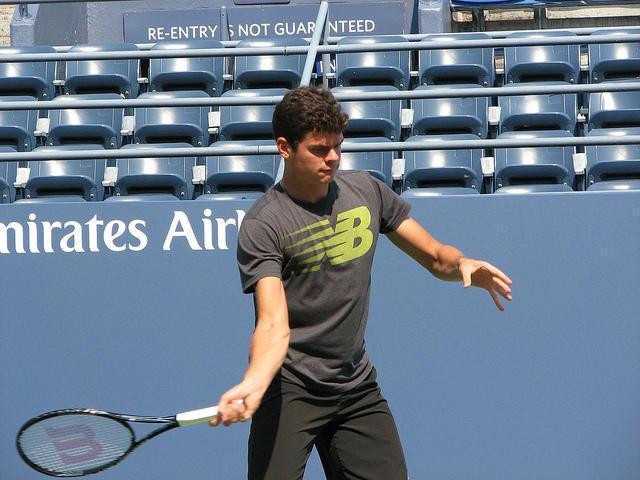What city is the sponsor of the arena located?
Make your selection and explain in format: 'Answer: answer
Rationale: rationale.'
Options: Dubai, denver, new york, calcutta. Answer: dubai.
Rationale: Emirates air is from the uae, and dubai is there. 